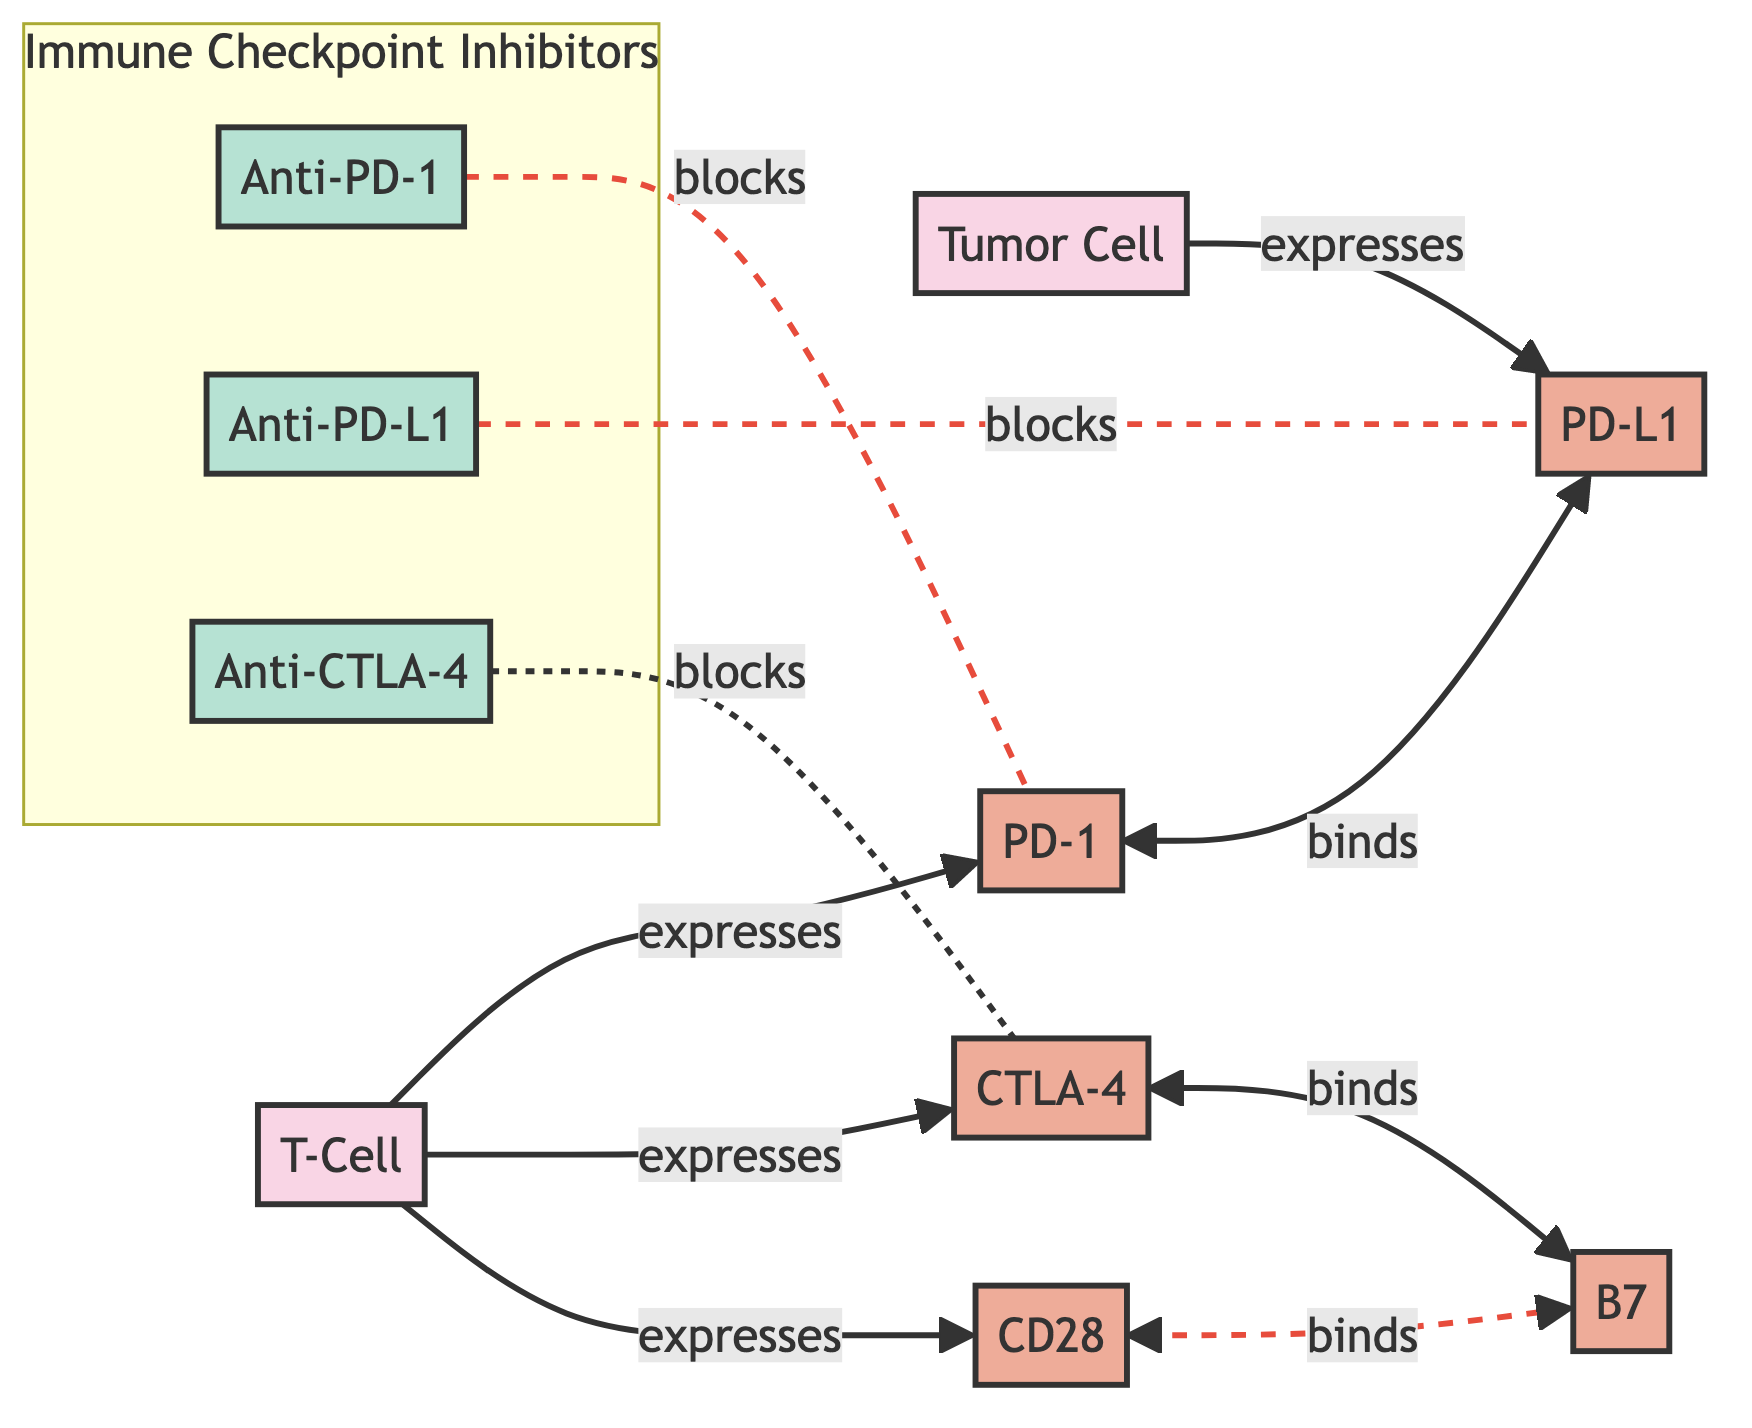What type of cells express PD-1? The diagram indicates that PD-1 is expressed by T-Cells. This is directly shown by the arrow from the T-Cell to PD-1 labeled "expresses".
Answer: T-Cell How many immune checkpoint inhibitors are depicted in the diagram? There are three immune checkpoint inhibitors: Anti-PD-1, Anti-PD-L1, and Anti-CTLA-4, all grouped under the "Immune Checkpoint Inhibitors" subgraph.
Answer: 3 Which protein binds to PD-L1? The diagram shows that PD-1 binds to PD-L1, indicated by the bidirectional arrow between these two proteins labeled "binds".
Answer: PD-1 What is the relationship between CTLA-4 and B7? The diagram illustrates that CTLA-4 binds to B7, indicated by the bidirectional arrow between CTLA-4 and B7 labeled "binds".
Answer: B7 Which checkpoint inhibitor blocks PD-1? The diagram specifies that Anti-PD-1 blocks PD-1, indicated by the dashed line labeled "blocks" from Anti-PD-1 to PD-1.
Answer: Anti-PD-1 What two proteins do T-Cells express according to the diagram? The diagram shows that T-Cells express PD-1 and CTLA-4. This is shown by the arrows labeled "expresses" pointing from T-Cell to PD-1 and CTLA-4.
Answer: PD-1, CTLA-4 Which drug is associated with blocking PD-L1? According to the diagram, Anti-PD-L1 is the drug that blocks PD-L1, shown by the dashed line labeled "blocks" from Anti-PD-L1 to PD-L1.
Answer: Anti-PD-L1 How do T-Cells interact with B7? The diagram indicates that T-Cells interact with B7 through CD28, as shown by the arrow from CD28 to B7 labeled "binds".
Answer: CD28 How many proteins are directly involved in the interactions depicted in the diagram? The diagram shows a total of five proteins involved in interactions: PD-1, PD-L1, CTLA-4, B7, and CD28.
Answer: 5 